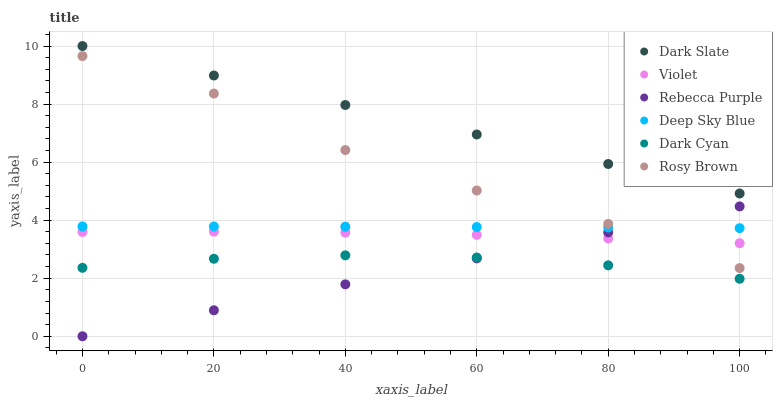Does Rebecca Purple have the minimum area under the curve?
Answer yes or no. Yes. Does Dark Slate have the maximum area under the curve?
Answer yes or no. Yes. Does Dark Slate have the minimum area under the curve?
Answer yes or no. No. Does Rebecca Purple have the maximum area under the curve?
Answer yes or no. No. Is Rebecca Purple the smoothest?
Answer yes or no. Yes. Is Rosy Brown the roughest?
Answer yes or no. Yes. Is Dark Slate the smoothest?
Answer yes or no. No. Is Dark Slate the roughest?
Answer yes or no. No. Does Rebecca Purple have the lowest value?
Answer yes or no. Yes. Does Dark Slate have the lowest value?
Answer yes or no. No. Does Dark Slate have the highest value?
Answer yes or no. Yes. Does Rebecca Purple have the highest value?
Answer yes or no. No. Is Deep Sky Blue less than Dark Slate?
Answer yes or no. Yes. Is Dark Slate greater than Deep Sky Blue?
Answer yes or no. Yes. Does Rebecca Purple intersect Violet?
Answer yes or no. Yes. Is Rebecca Purple less than Violet?
Answer yes or no. No. Is Rebecca Purple greater than Violet?
Answer yes or no. No. Does Deep Sky Blue intersect Dark Slate?
Answer yes or no. No. 